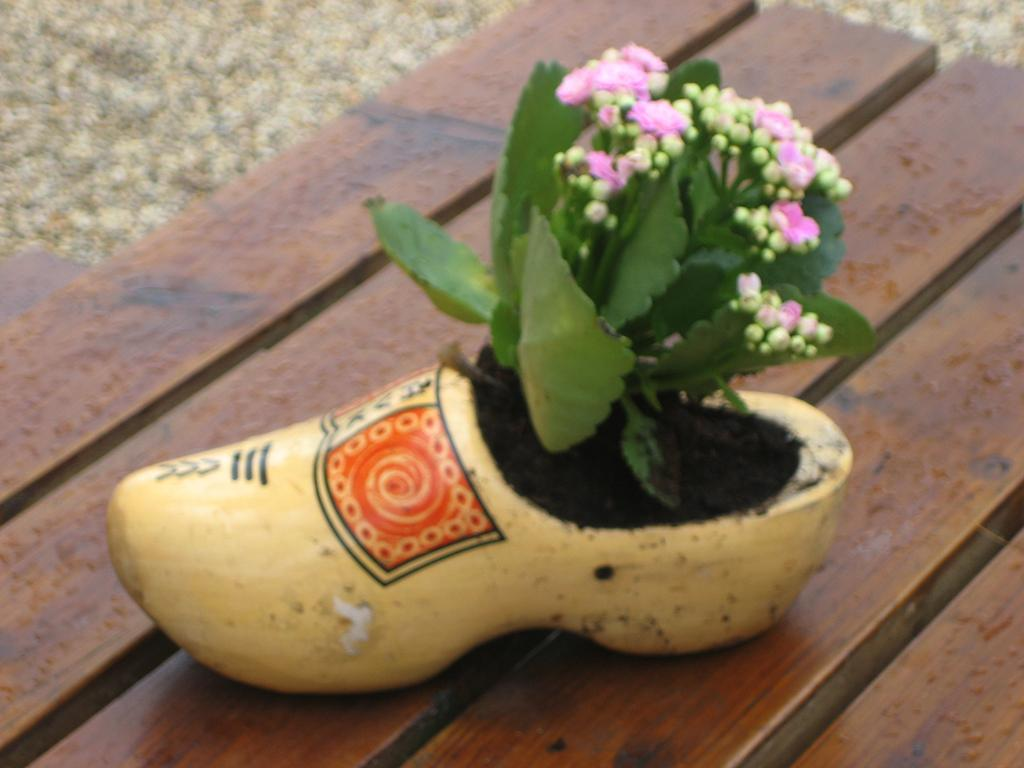What type of surface is visible in the image? There is a wooden surface in the image. What is placed on the wooden surface? There is a pot in the shape of a shoe on the wooden surface. What is inside the pot? The pot contains a plant. What is special about the plant? The plant has flowers. How many dogs are visible in the image? There are no dogs present in the image. What type of screw is holding the pot in the image? There is no screw visible in the image; the pot is placed on a wooden surface. 